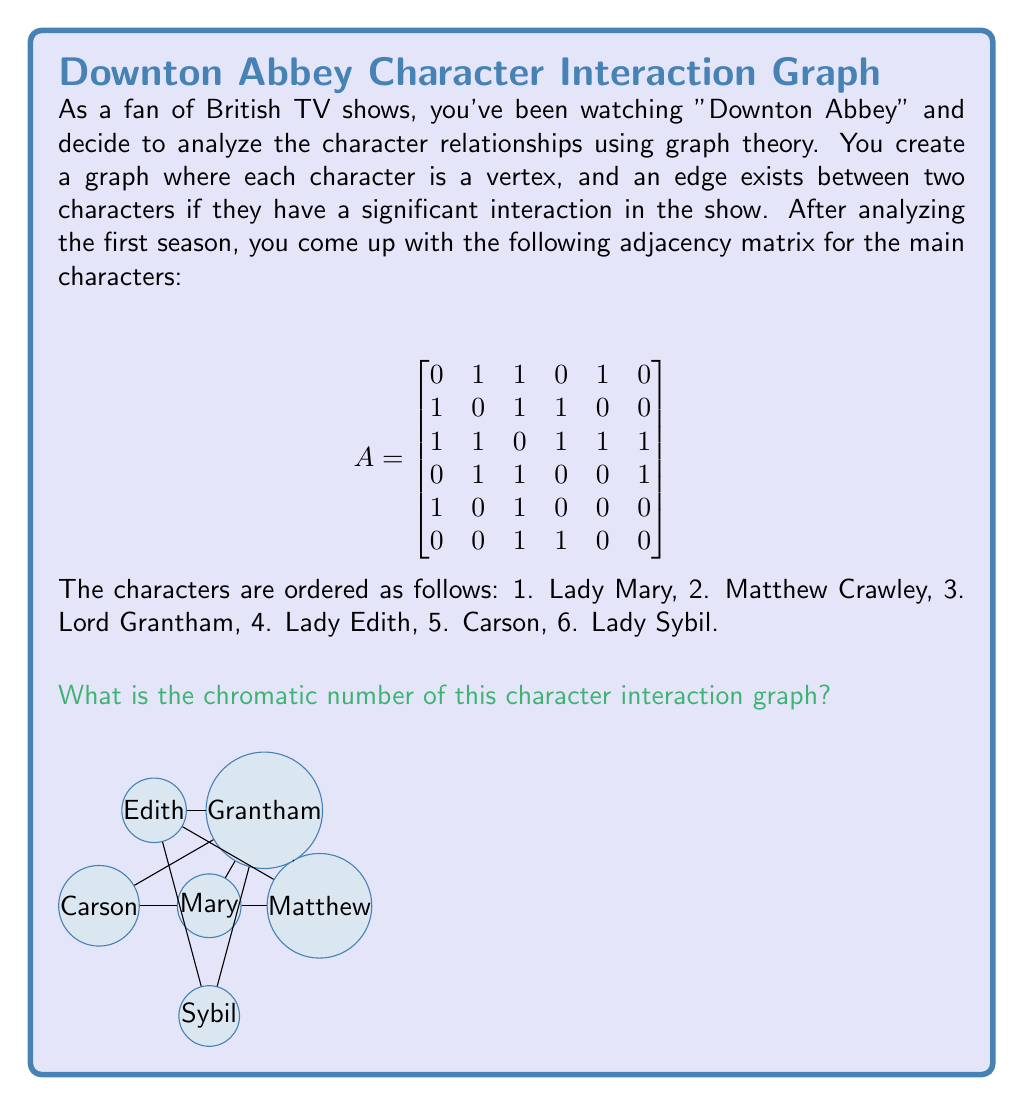Help me with this question. To find the chromatic number of this graph, we need to determine the minimum number of colors required to color all vertices such that no two adjacent vertices have the same color. Let's approach this step-by-step:

1) First, let's identify the degree of each vertex:
   Lady Mary (1): degree 3
   Matthew Crawley (2): degree 3
   Lord Grantham (3): degree 5
   Lady Edith (4): degree 3
   Carson (5): degree 2
   Lady Sybil (6): degree 2

2) We can start by coloring the vertex with the highest degree, Lord Grantham, as it's likely to be the most constrained. Let's color it red.

3) All vertices adjacent to Lord Grantham must have different colors. These are Mary, Matthew, Edith, Carson, and Sybil. We can color them as follows:
   Mary: Blue
   Matthew: Green
   Edith: Yellow
   Carson: Blue (as it's not adjacent to Mary)
   Sybil: Blue (as it's not adjacent to Mary or Carson)

4) We've used 4 colors so far (Red, Blue, Green, Yellow), and all vertices are colored without conflicts.

5) To check if we can use fewer colors, let's try to eliminate one color:
   - We can't eliminate Red, as Lord Grantham is adjacent to all other colors.
   - We can't eliminate Blue, as Mary, Carson, and Sybil form an independent set.
   - We can't eliminate Green or Yellow, as Matthew and Edith are adjacent.

Therefore, 4 is the minimum number of colors needed.

The chromatic number of a graph is defined as the minimum number of colors needed in a proper coloring of the graph. In this case, that number is 4.
Answer: 4 